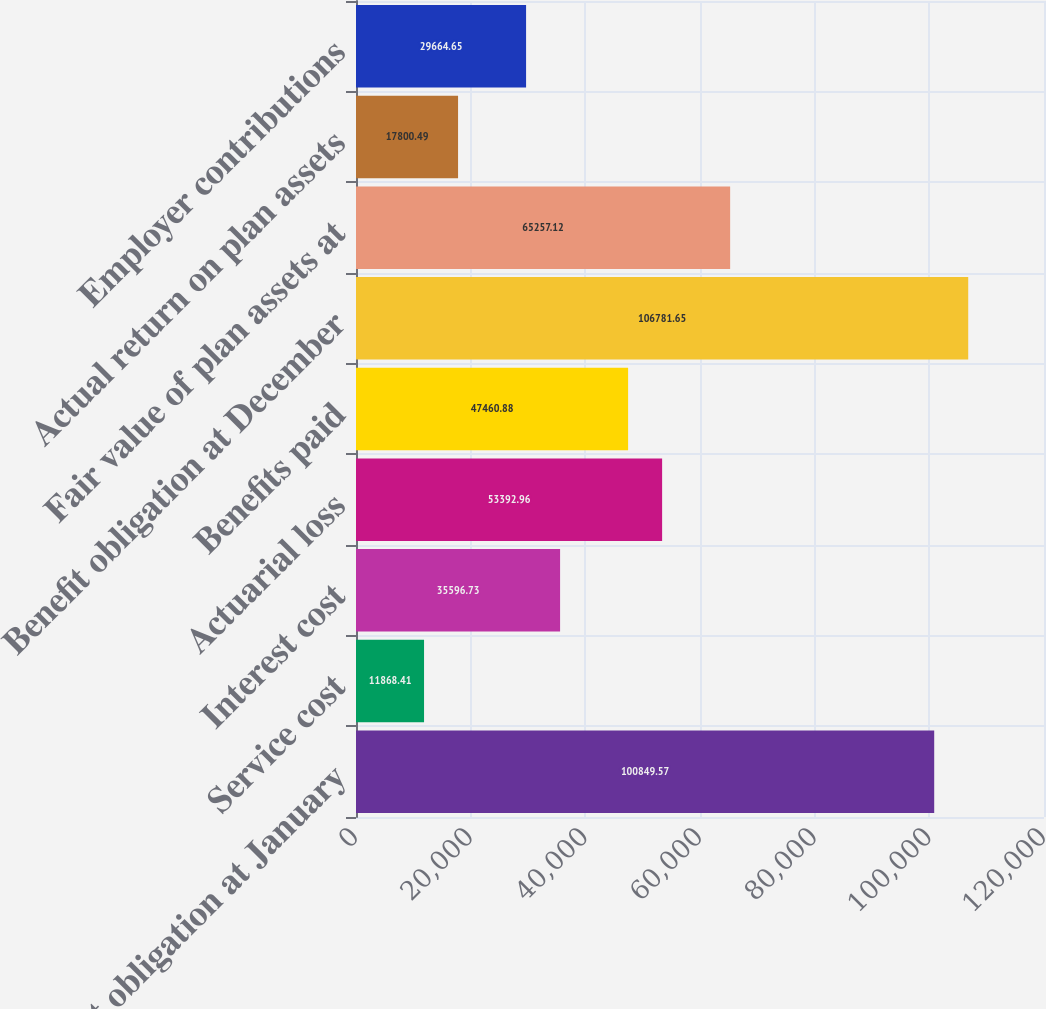<chart> <loc_0><loc_0><loc_500><loc_500><bar_chart><fcel>Benefit obligation at January<fcel>Service cost<fcel>Interest cost<fcel>Actuarial loss<fcel>Benefits paid<fcel>Benefit obligation at December<fcel>Fair value of plan assets at<fcel>Actual return on plan assets<fcel>Employer contributions<nl><fcel>100850<fcel>11868.4<fcel>35596.7<fcel>53393<fcel>47460.9<fcel>106782<fcel>65257.1<fcel>17800.5<fcel>29664.7<nl></chart> 